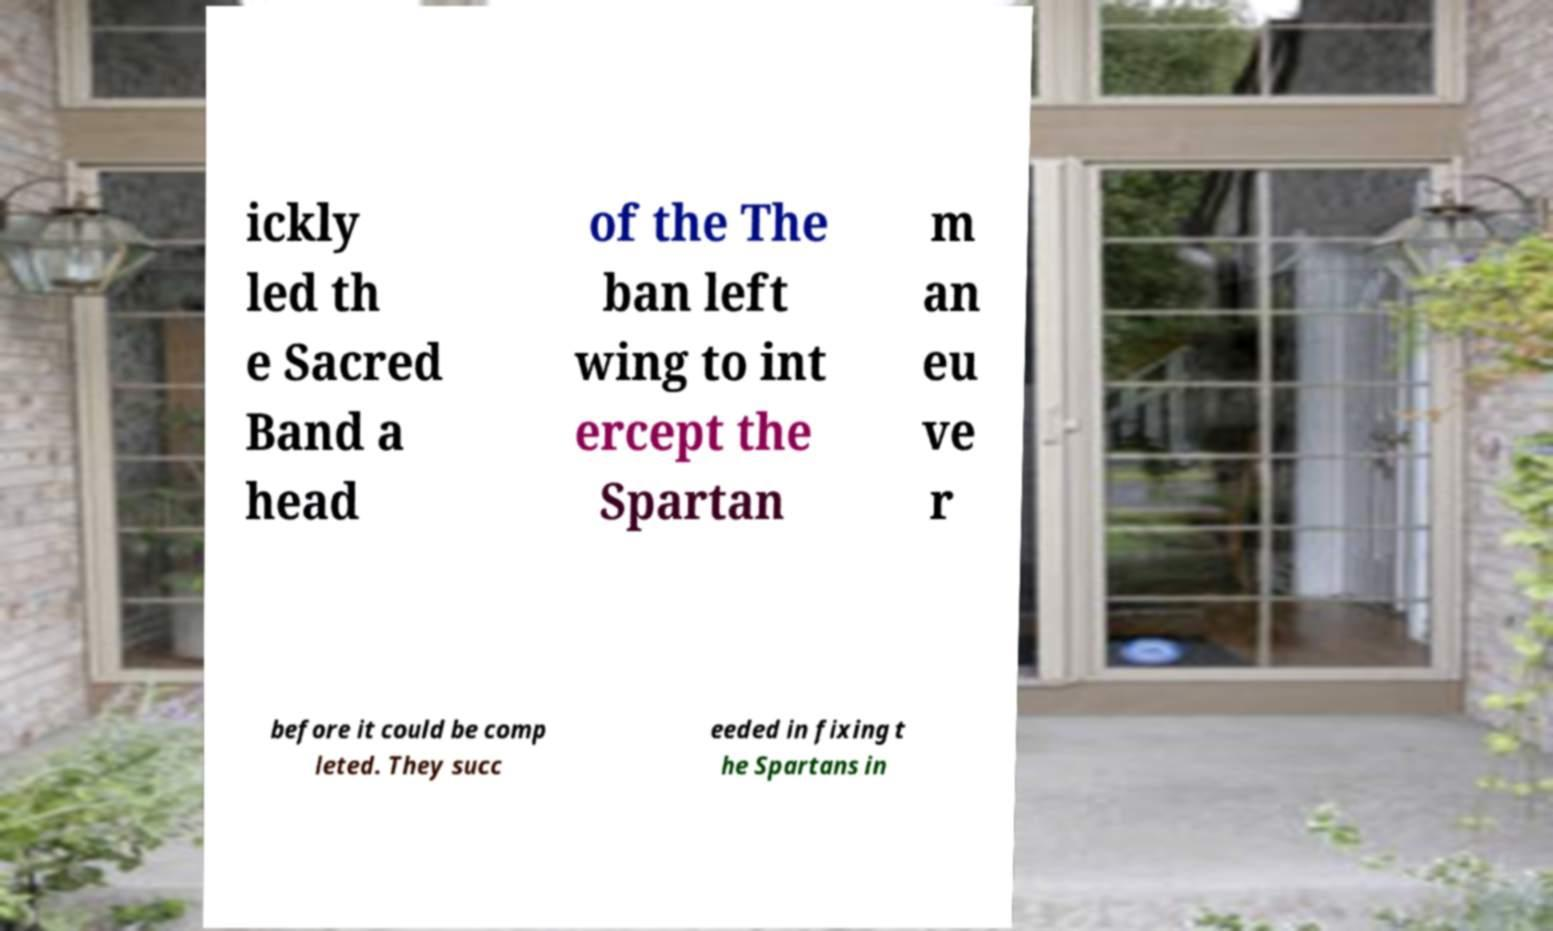What messages or text are displayed in this image? I need them in a readable, typed format. ickly led th e Sacred Band a head of the The ban left wing to int ercept the Spartan m an eu ve r before it could be comp leted. They succ eeded in fixing t he Spartans in 